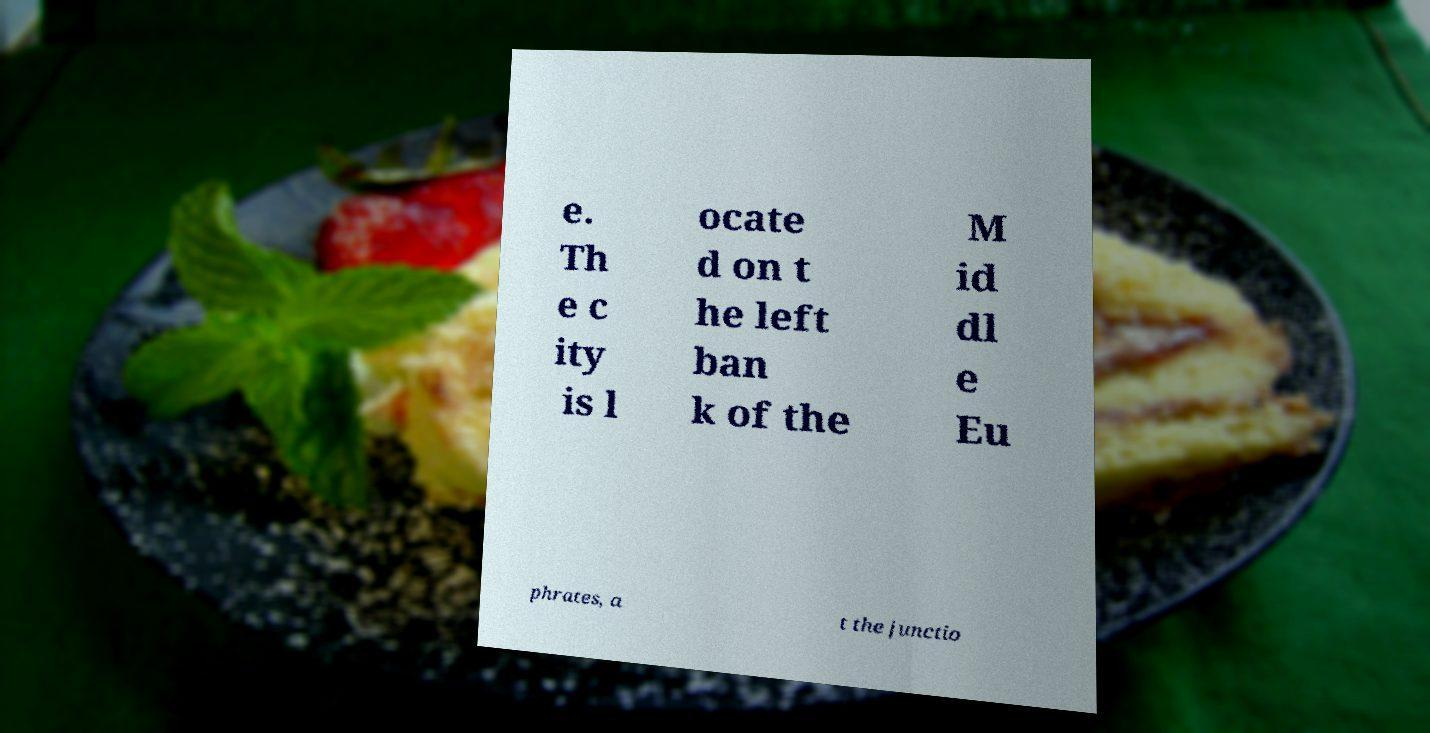Can you read and provide the text displayed in the image?This photo seems to have some interesting text. Can you extract and type it out for me? e. Th e c ity is l ocate d on t he left ban k of the M id dl e Eu phrates, a t the junctio 